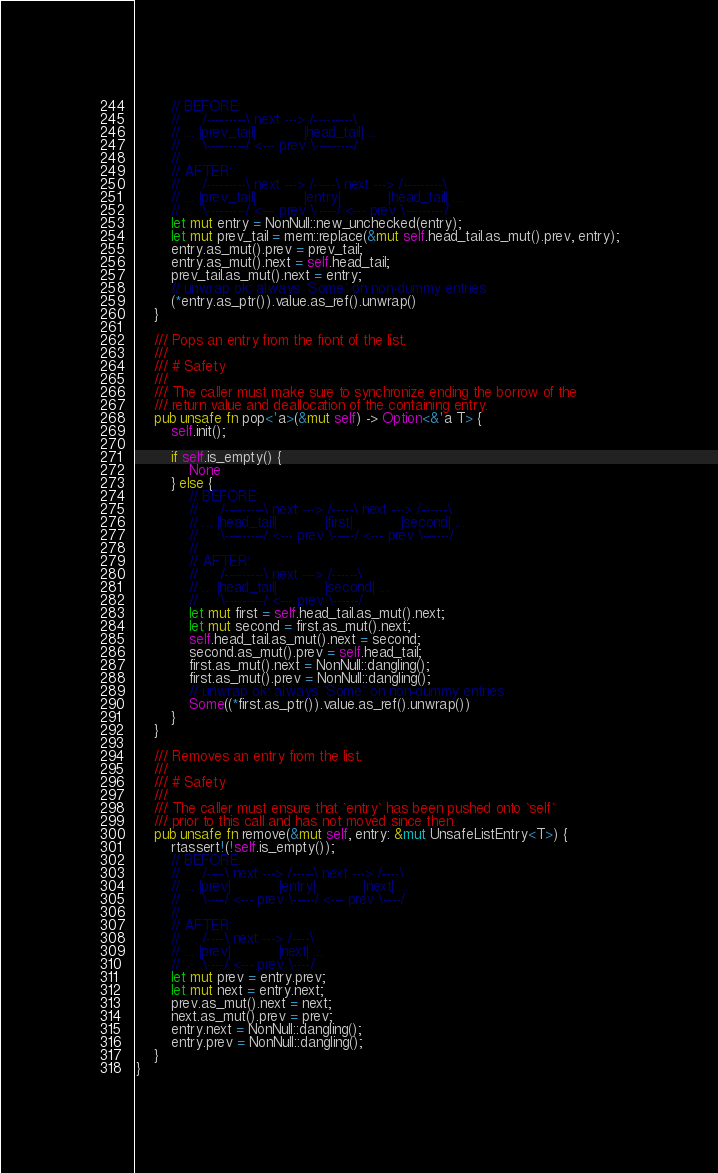<code> <loc_0><loc_0><loc_500><loc_500><_Rust_>        // BEFORE:
        //     /---------\ next ---> /---------\
        // ... |prev_tail|           |head_tail| ...
        //     \---------/ <--- prev \---------/
        //
        // AFTER:
        //     /---------\ next ---> /-----\ next ---> /---------\
        // ... |prev_tail|           |entry|           |head_tail| ...
        //     \---------/ <--- prev \-----/ <--- prev \---------/
        let mut entry = NonNull::new_unchecked(entry);
        let mut prev_tail = mem::replace(&mut self.head_tail.as_mut().prev, entry);
        entry.as_mut().prev = prev_tail;
        entry.as_mut().next = self.head_tail;
        prev_tail.as_mut().next = entry;
        // unwrap ok: always `Some` on non-dummy entries
        (*entry.as_ptr()).value.as_ref().unwrap()
    }

    /// Pops an entry from the front of the list.
    ///
    /// # Safety
    ///
    /// The caller must make sure to synchronize ending the borrow of the
    /// return value and deallocation of the containing entry.
    pub unsafe fn pop<'a>(&mut self) -> Option<&'a T> {
        self.init();

        if self.is_empty() {
            None
        } else {
            // BEFORE:
            //     /---------\ next ---> /-----\ next ---> /------\
            // ... |head_tail|           |first|           |second| ...
            //     \---------/ <--- prev \-----/ <--- prev \------/
            //
            // AFTER:
            //     /---------\ next ---> /------\
            // ... |head_tail|           |second| ...
            //     \---------/ <--- prev \------/
            let mut first = self.head_tail.as_mut().next;
            let mut second = first.as_mut().next;
            self.head_tail.as_mut().next = second;
            second.as_mut().prev = self.head_tail;
            first.as_mut().next = NonNull::dangling();
            first.as_mut().prev = NonNull::dangling();
            // unwrap ok: always `Some` on non-dummy entries
            Some((*first.as_ptr()).value.as_ref().unwrap())
        }
    }

    /// Removes an entry from the list.
    ///
    /// # Safety
    ///
    /// The caller must ensure that `entry` has been pushed onto `self`
    /// prior to this call and has not moved since then.
    pub unsafe fn remove(&mut self, entry: &mut UnsafeListEntry<T>) {
        rtassert!(!self.is_empty());
        // BEFORE:
        //     /----\ next ---> /-----\ next ---> /----\
        // ... |prev|           |entry|           |next| ...
        //     \----/ <--- prev \-----/ <--- prev \----/
        //
        // AFTER:
        //     /----\ next ---> /----\
        // ... |prev|           |next| ...
        //     \----/ <--- prev \----/
        let mut prev = entry.prev;
        let mut next = entry.next;
        prev.as_mut().next = next;
        next.as_mut().prev = prev;
        entry.next = NonNull::dangling();
        entry.prev = NonNull::dangling();
    }
}
</code> 